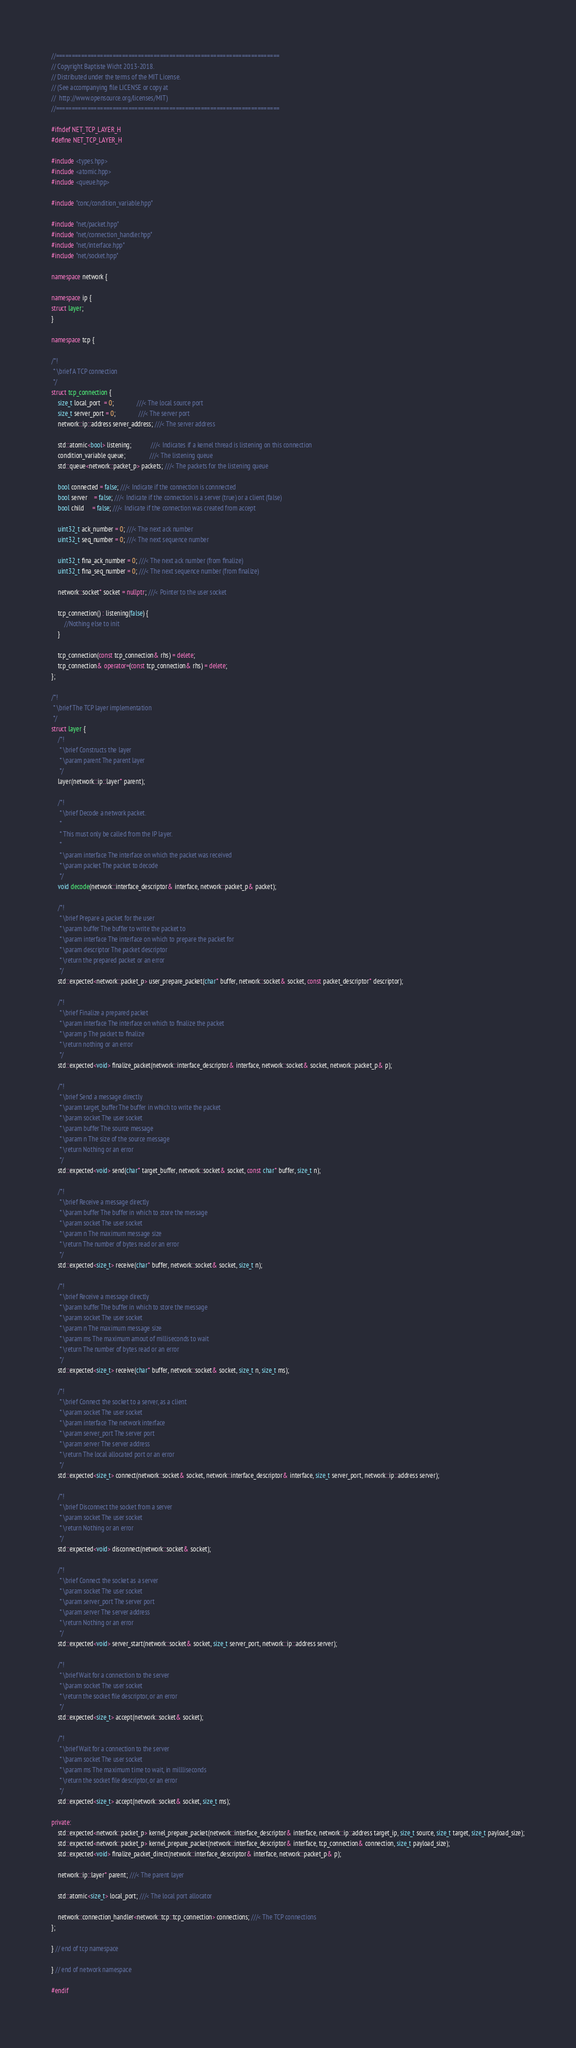<code> <loc_0><loc_0><loc_500><loc_500><_C++_>//=======================================================================
// Copyright Baptiste Wicht 2013-2018.
// Distributed under the terms of the MIT License.
// (See accompanying file LICENSE or copy at
//  http://www.opensource.org/licenses/MIT)
//=======================================================================

#ifndef NET_TCP_LAYER_H
#define NET_TCP_LAYER_H

#include <types.hpp>
#include <atomic.hpp>
#include <queue.hpp>

#include "conc/condition_variable.hpp"

#include "net/packet.hpp"
#include "net/connection_handler.hpp"
#include "net/interface.hpp"
#include "net/socket.hpp"

namespace network {

namespace ip {
struct layer;
}

namespace tcp {

/*!
 * \brief A TCP connection
 */
struct tcp_connection {
    size_t local_port  = 0;              ///< The local source port
    size_t server_port = 0;              ///< The server port
    network::ip::address server_address; ///< The server address

    std::atomic<bool> listening;            ///< Indicates if a kernel thread is listening on this connection
    condition_variable queue;               ///< The listening queue
    std::queue<network::packet_p> packets; ///< The packets for the listening queue

    bool connected = false; ///< Indicate if the connection is connnected
    bool server    = false; ///< Indicate if the connection is a server (true) or a client (false)
    bool child     = false; ///< Indicate if the connection was created from accept

    uint32_t ack_number = 0; ///< The next ack number
    uint32_t seq_number = 0; ///< The next sequence number

    uint32_t fina_ack_number = 0; ///< The next ack number (from finalize)
    uint32_t fina_seq_number = 0; ///< The next sequence number (from finalize)

    network::socket* socket = nullptr; ///< Pointer to the user socket

    tcp_connection() : listening(false) {
        //Nothing else to init
    }

    tcp_connection(const tcp_connection& rhs) = delete;
    tcp_connection& operator=(const tcp_connection& rhs) = delete;
};

/*!
 * \brief The TCP layer implementation
 */
struct layer {
    /*!
     * \brief Constructs the layer
     * \param parent The parent layer
     */
    layer(network::ip::layer* parent);

    /*!
     * \brief Decode a network packet.
     *
     * This must only be called from the IP layer.
     *
     * \param interface The interface on which the packet was received
     * \param packet The packet to decode
     */
    void decode(network::interface_descriptor& interface, network::packet_p& packet);

    /*!
     * \brief Prepare a packet for the user
     * \param buffer The buffer to write the packet to
     * \param interface The interface on which to prepare the packet for
     * \param descriptor The packet descriptor
     * \return the prepared packet or an error
     */
    std::expected<network::packet_p> user_prepare_packet(char* buffer, network::socket& socket, const packet_descriptor* descriptor);

    /*!
     * \brief Finalize a prepared packet
     * \param interface The interface on which to finalize the packet
     * \param p The packet to finalize
     * \return nothing or an error
     */
    std::expected<void> finalize_packet(network::interface_descriptor& interface, network::socket& socket, network::packet_p& p);

    /*!
     * \brief Send a message directly
     * \param target_buffer The buffer in which to write the packet
     * \þaram socket The user socket
     * \param buffer The source message
     * \param n The size of the source message
     * \return Nothing or an error
     */
    std::expected<void> send(char* target_buffer, network::socket& socket, const char* buffer, size_t n);

    /*!
     * \brief Receive a message directly
     * \þaram buffer The buffer in which to store the message
     * \param socket The user socket
     * \param n The maximum message size
     * \return The number of bytes read or an error
     */
    std::expected<size_t> receive(char* buffer, network::socket& socket, size_t n);

    /*!
     * \brief Receive a message directly
     * \þaram buffer The buffer in which to store the message
     * \param socket The user socket
     * \param n The maximum message size
     * \param ms The maximum amout of milliseconds to wait
     * \return The number of bytes read or an error
     */
    std::expected<size_t> receive(char* buffer, network::socket& socket, size_t n, size_t ms);

    /*!
     * \brief Connect the socket to a server, as a client
     * \param socket The user socket
     * \þaram interface The network interface
     * \param server_port The server port
     * \param server The server address
     * \return The local allocated port or an error
     */
    std::expected<size_t> connect(network::socket& socket, network::interface_descriptor& interface, size_t server_port, network::ip::address server);

    /*!
     * \brief Disconnect the socket from a server
     * \param socket The user socket
     * \return Nothing or an error
     */
    std::expected<void> disconnect(network::socket& socket);

    /*!
     * \brief Connect the socket as a server
     * \param socket The user socket
     * \param server_port The server port
     * \param server The server address
     * \return Nothing or an error
     */
    std::expected<void> server_start(network::socket& socket, size_t server_port, network::ip::address server);

    /*!
     * \brief Wait for a connection to the server
     * \þaram socket The user socket
     * \return the socket file descriptor, or an error
     */
    std::expected<size_t> accept(network::socket& socket);

    /*!
     * \brief Wait for a connection to the server
     * \þaram socket The user socket
     * \param ms The maximum time to wait, in millliseconds
     * \return the socket file descriptor, or an error
     */
    std::expected<size_t> accept(network::socket& socket, size_t ms);

private:
    std::expected<network::packet_p> kernel_prepare_packet(network::interface_descriptor& interface, network::ip::address target_ip, size_t source, size_t target, size_t payload_size);
    std::expected<network::packet_p> kernel_prepare_packet(network::interface_descriptor& interface, tcp_connection& connection, size_t payload_size);
    std::expected<void> finalize_packet_direct(network::interface_descriptor& interface, network::packet_p& p);

    network::ip::layer* parent; ///< The parent layer

    std::atomic<size_t> local_port; ///< The local port allocator

    network::connection_handler<network::tcp::tcp_connection> connections; ///< The TCP connections
};

} // end of tcp namespace

} // end of network namespace

#endif
</code> 